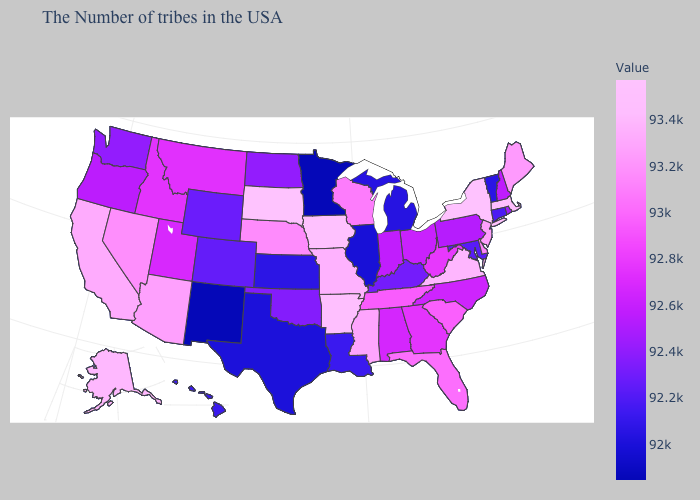Among the states that border Louisiana , does Texas have the lowest value?
Answer briefly. Yes. Which states have the lowest value in the West?
Be succinct. New Mexico. Does the map have missing data?
Quick response, please. No. Does Georgia have a lower value than Arkansas?
Keep it brief. Yes. Among the states that border New Mexico , which have the lowest value?
Give a very brief answer. Texas. 